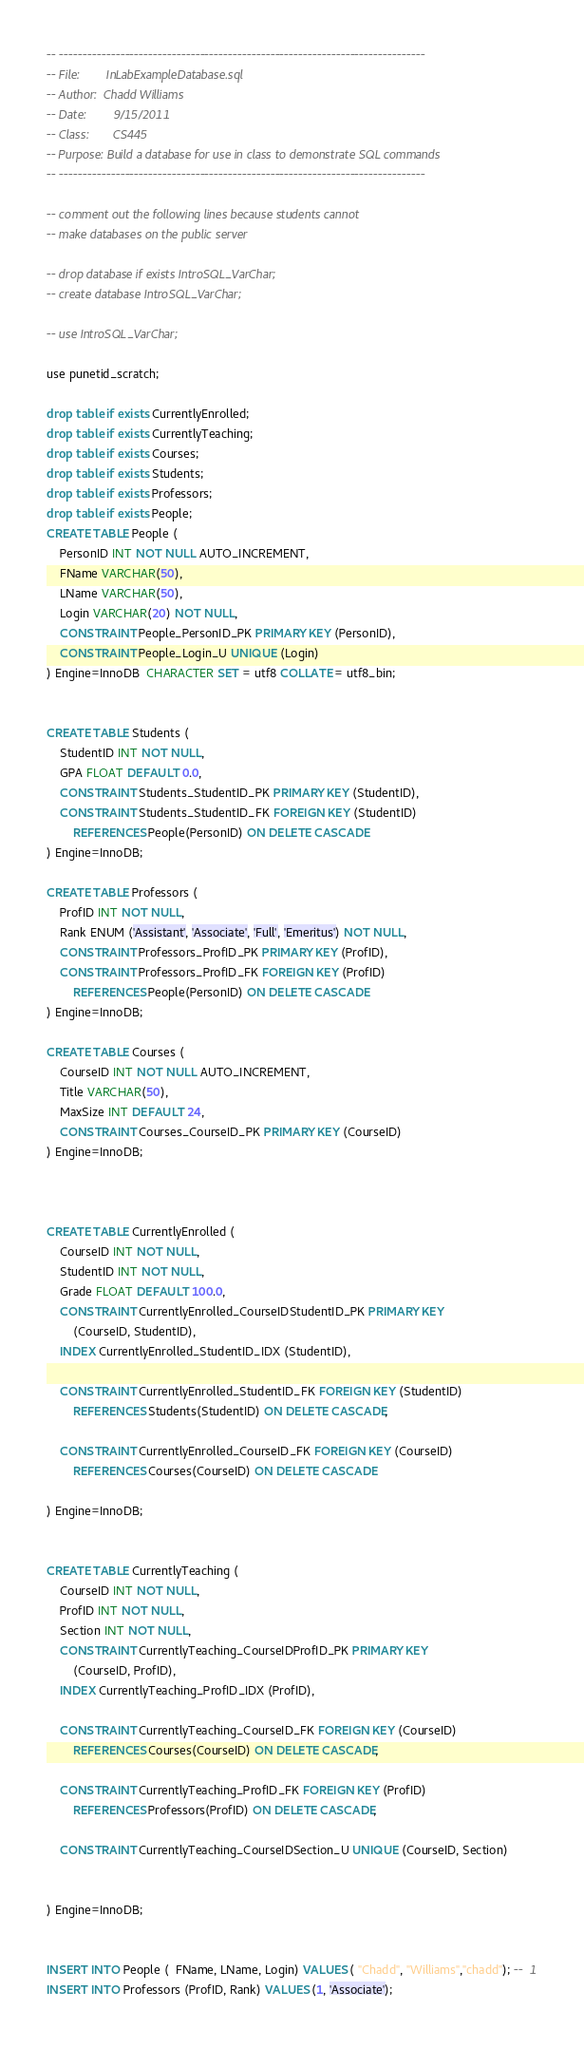Convert code to text. <code><loc_0><loc_0><loc_500><loc_500><_SQL_>-- ------------------------------------------------------------------------------
-- File: 		InLabExampleDatabase.sql
-- Author:	Chadd Williams
-- Date: 		9/15/2011
-- Class:		CS445
-- Purpose:	Build a database for use in class to demonstrate SQL commands
-- ------------------------------------------------------------------------------

-- comment out the following lines because students cannot
-- make databases on the public server

-- drop database if exists IntroSQL_VarChar;
-- create database IntroSQL_VarChar;

-- use IntroSQL_VarChar;

use punetid_scratch;

drop table if exists CurrentlyEnrolled;
drop table if exists CurrentlyTeaching;
drop table if exists Courses;
drop table if exists Students;
drop table if exists Professors;
drop table if exists People;
CREATE TABLE People (
	PersonID INT NOT NULL AUTO_INCREMENT,
	FName VARCHAR(50),
	LName VARCHAR(50),
	Login VARCHAR(20) NOT NULL,
	CONSTRAINT People_PersonID_PK PRIMARY KEY (PersonID),
	CONSTRAINT People_Login_U UNIQUE (Login)
) Engine=InnoDB  CHARACTER SET = utf8 COLLATE = utf8_bin;


CREATE TABLE Students (
	StudentID INT NOT NULL,
	GPA FLOAT DEFAULT 0.0,
	CONSTRAINT Students_StudentID_PK PRIMARY KEY (StudentID),
	CONSTRAINT Students_StudentID_FK FOREIGN KEY (StudentID) 
		REFERENCES People(PersonID) ON DELETE CASCADE
) Engine=InnoDB;

CREATE TABLE Professors (
	ProfID INT NOT NULL,
	Rank ENUM ('Assistant', 'Associate', 'Full', 'Emeritus') NOT NULL,
	CONSTRAINT Professors_ProfID_PK PRIMARY KEY (ProfID),
	CONSTRAINT Professors_ProfID_FK FOREIGN KEY (ProfID) 
		REFERENCES People(PersonID) ON DELETE CASCADE
) Engine=InnoDB;

CREATE TABLE Courses (
	CourseID INT NOT NULL AUTO_INCREMENT,
	Title VARCHAR(50),
	MaxSize INT DEFAULT 24,
	CONSTRAINT Courses_CourseID_PK PRIMARY KEY (CourseID)
) Engine=InnoDB;



CREATE TABLE CurrentlyEnrolled (
	CourseID INT NOT NULL,
	StudentID INT NOT NULL,
	Grade FLOAT DEFAULT 100.0,
	CONSTRAINT CurrentlyEnrolled_CourseIDStudentID_PK PRIMARY KEY 
		(CourseID, StudentID),
	INDEX CurrentlyEnrolled_StudentID_IDX (StudentID),
	
	CONSTRAINT CurrentlyEnrolled_StudentID_FK FOREIGN KEY (StudentID) 
		REFERENCES Students(StudentID) ON DELETE CASCADE,
		
	CONSTRAINT CurrentlyEnrolled_CourseID_FK FOREIGN KEY (CourseID) 
		REFERENCES Courses(CourseID) ON DELETE CASCADE

) Engine=InnoDB;

	
CREATE TABLE CurrentlyTeaching (
	CourseID INT NOT NULL,
	ProfID INT NOT NULL,
	Section INT NOT NULL,
	CONSTRAINT CurrentlyTeaching_CourseIDProfID_PK PRIMARY KEY 
		(CourseID, ProfID),
	INDEX CurrentlyTeaching_ProfID_IDX (ProfID),

	CONSTRAINT CurrentlyTeaching_CourseID_FK FOREIGN KEY (CourseID) 
		REFERENCES Courses(CourseID) ON DELETE CASCADE,

	CONSTRAINT CurrentlyTeaching_ProfID_FK FOREIGN KEY (ProfID) 
		REFERENCES Professors(ProfID) ON DELETE CASCADE,

	CONSTRAINT CurrentlyTeaching_CourseIDSection_U UNIQUE (CourseID, Section) 
		

) Engine=InnoDB;


INSERT INTO People (  FName, LName, Login) VALUES ( "Chadd", "Williams","chadd"); --  1
INSERT INTO Professors (ProfID, Rank) VALUES (1, 'Associate');
</code> 